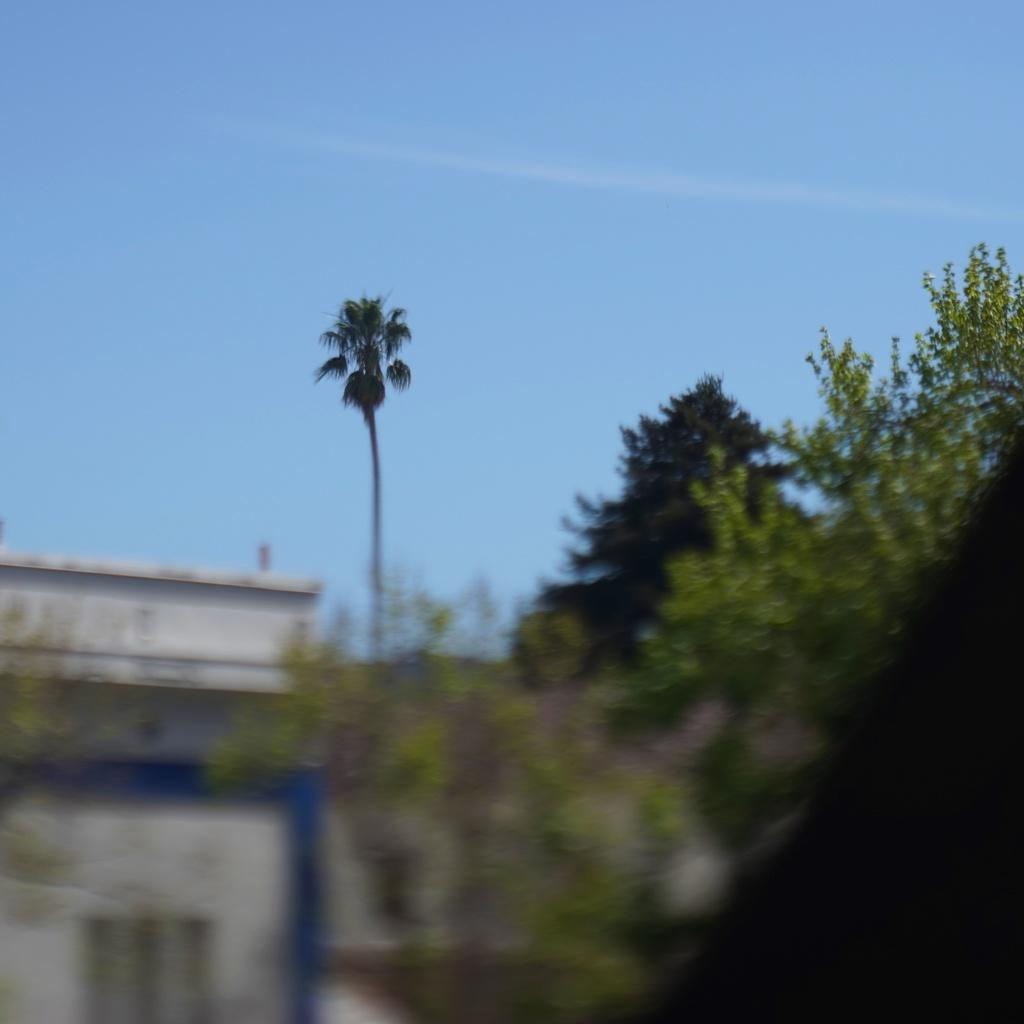What type of vegetation can be seen in the image? There are trees in the image. What type of structure is present in the image? There is a building in the image. What is visible at the top of the image? The sky is visible at the top of the image. Can you see any signs of regret on the trees in the image? There is no indication of regret in the image, as it features trees and a building with a visible sky. Is the seashore visible in the image? There is no seashore present in the image; it features trees, a building, and the sky. 